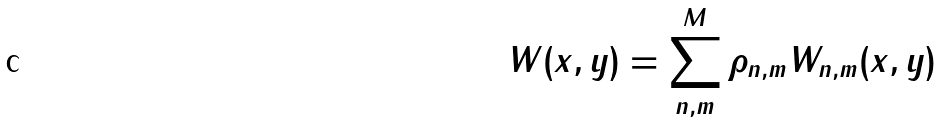<formula> <loc_0><loc_0><loc_500><loc_500>W ( x , y ) = \sum _ { n , m } ^ { M } \rho _ { n , m } W _ { n , m } ( x , y )</formula> 